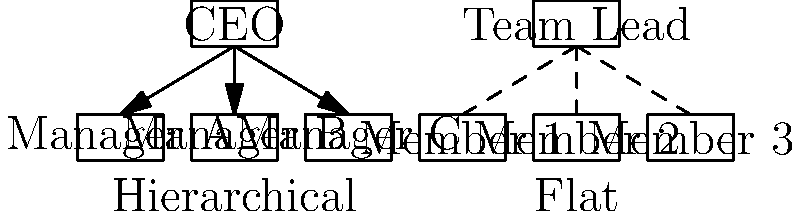As a psychologist studying organizational structures, analyze the two leadership styles depicted in the organizational charts. How might these different structures impact team dynamics, communication, and decision-making processes? Which structure would be more suitable for a fast-paced, innovative environment, and why? 1. Hierarchical Structure (left):
   - Clear chain of command: CEO at the top, followed by managers
   - Vertical communication flow
   - Centralized decision-making

2. Flat Structure (right):
   - Minimal hierarchy: Team lead and team members on similar levels
   - Horizontal communication flow
   - Decentralized decision-making

3. Impact on team dynamics:
   - Hierarchical: May create power distances, formal relationships
   - Flat: Encourages collaboration, informal relationships

4. Impact on communication:
   - Hierarchical: Information may be filtered through layers
   - Flat: Direct communication between all team members

5. Impact on decision-making:
   - Hierarchical: Decisions made at the top, potentially slower
   - Flat: Faster decision-making, more employee involvement

6. Suitability for fast-paced, innovative environment:
   - Flat structure is more suitable because:
     a. Faster communication and decision-making
     b. Encourages creativity and idea-sharing
     c. Adaptable to rapid changes
     d. Empowers employees, increasing motivation and engagement

7. Psychological considerations:
   - Flat structure aligns with self-determination theory, promoting autonomy and competence
   - Reduces power dynamics that may hinder innovation
   - Supports psychological safety, crucial for innovation
Answer: Flat structure, due to faster communication, decentralized decision-making, and increased employee empowerment, which fosters innovation and adaptability. 